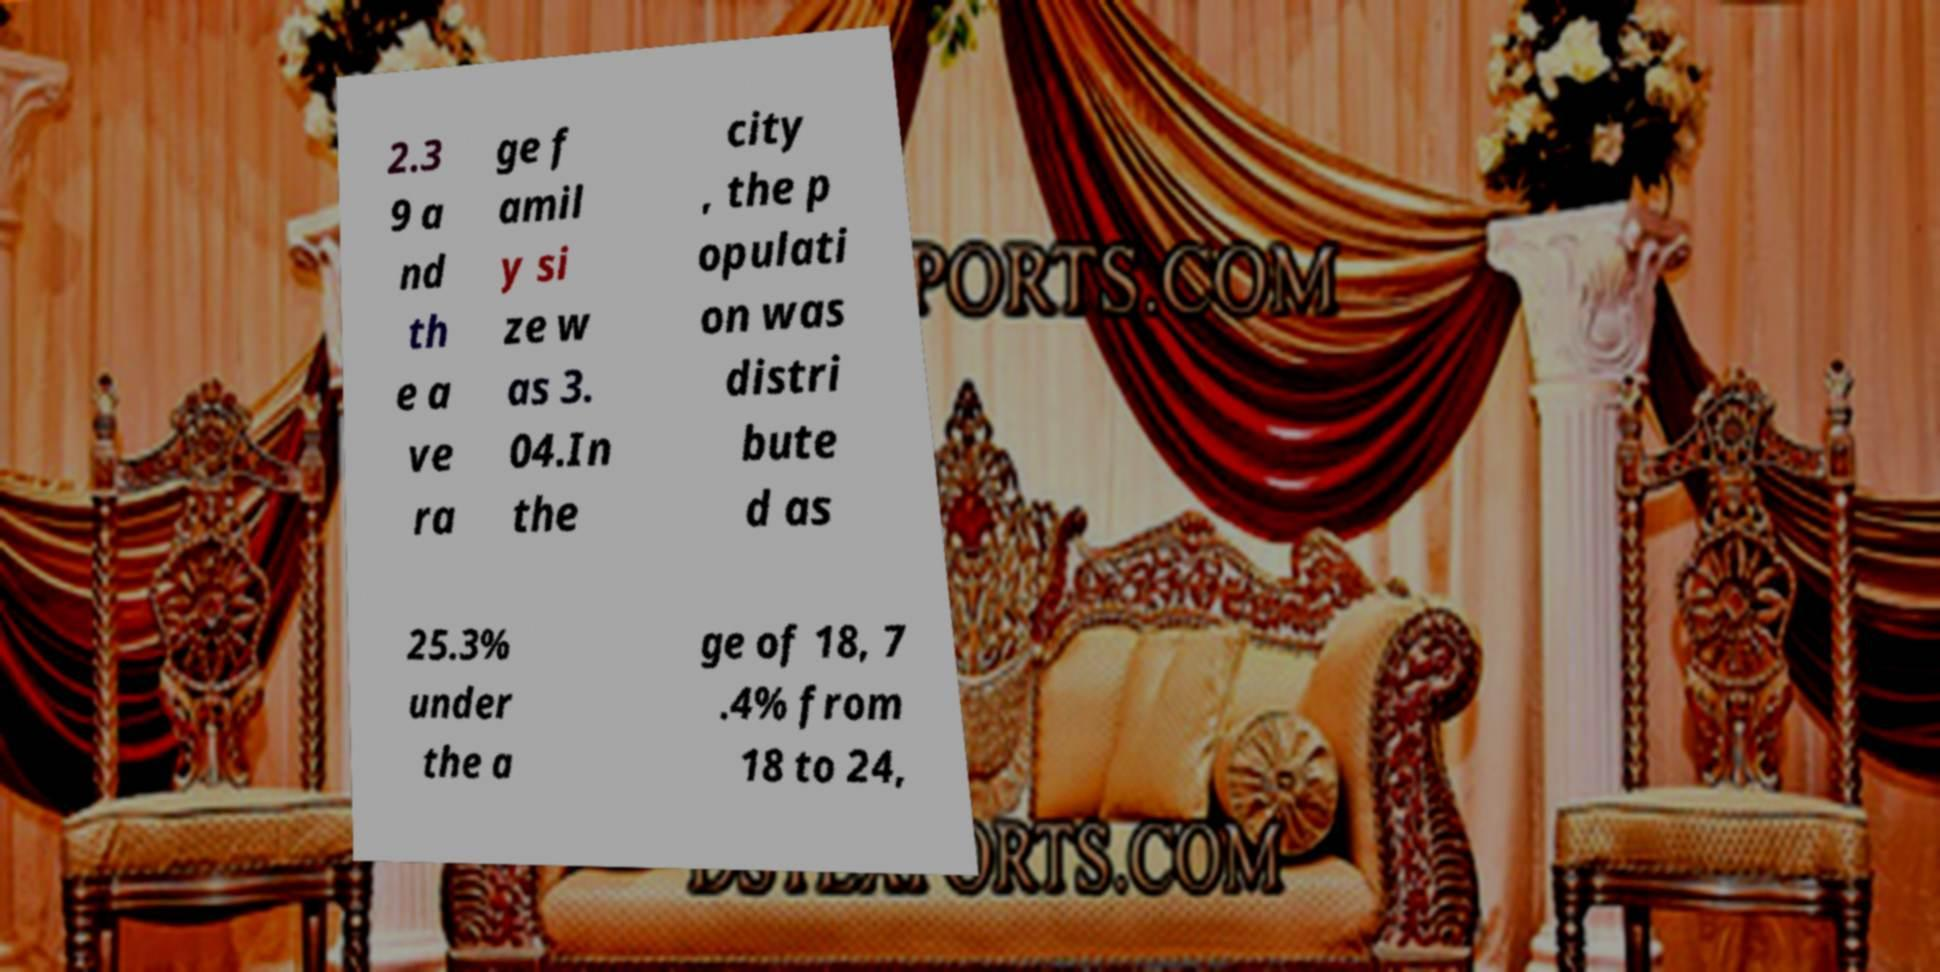There's text embedded in this image that I need extracted. Can you transcribe it verbatim? 2.3 9 a nd th e a ve ra ge f amil y si ze w as 3. 04.In the city , the p opulati on was distri bute d as 25.3% under the a ge of 18, 7 .4% from 18 to 24, 